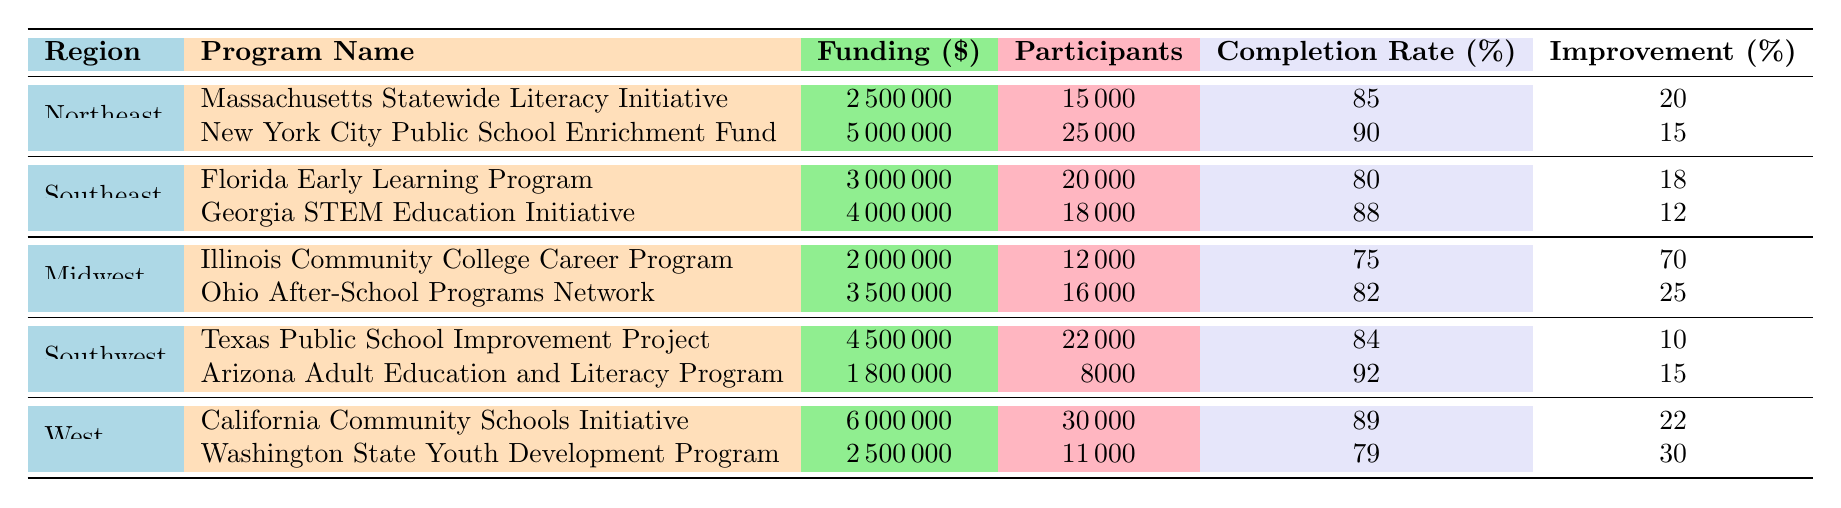What is the funding amount for the Georgia STEM Education Initiative? The table shows the Southeast region's programs. Looking at the entry for the Georgia STEM Education Initiative, the funding amount is listed as 4000000.
Answer: 4000000 Which region has the highest average completion rate among its programs? First, we calculate the average completion rates for each region: Northeast (87.5), Southeast (84), Midwest (78.5), Southwest (88), and West (84). The highest average is 88 from the Southwest region.
Answer: Southwest Did the Massachusetts Statewide Literacy Initiative improve literacy rates by more than 20 percent? The improvement in literacy rate for the Massachusetts Statewide Literacy Initiative is explicitly listed as 20 percent. Therefore, the statement is false.
Answer: No How many participants were there in total across all programs in the Midwest? To find the total participants in the Midwest, we add the numbers from both programs: 12000 (Illinois Community College Career Program) + 16000 (Ohio After-School Programs Network) = 28000.
Answer: 28000 Is the completion rate for the Florida Early Learning Program higher than that of the Texas Public School Improvement Project? The completion rate for the Florida Early Learning Program is 80 percent, while the Texas Public School Improvement Project has a completion rate of 84 percent, making this statement false.
Answer: No Which program in the West region had the highest funding amount? In the West region, we compare the funding amounts for both programs: California Community Schools Initiative at 6000000 and Washington State Youth Development Program at 2500000. The California Community Schools Initiative has the highest funding amount.
Answer: California Community Schools Initiative What is the total funding amount for all programs in the Northeast? First, we sum the funding amounts for the programs in the Northeast: 2500000 (Massachusetts Statewide Literacy Initiative) + 5000000 (New York City Public School Enrichment Fund) = 7500000.
Answer: 7500000 How does the improvement in employment rate for the Arizona Adult Education and Literacy Program compare to that of the Georgia STEM Education Initiative? The Arizona Adult Education and Literacy Program has an improvement of 15 percent in employment rate, while the Georgia STEM Education Initiative has an improvement of 12 percent. Hence, Arizona has a higher improvement rate.
Answer: Higher in Arizona What is the difference in completion rates between the California Community Schools Initiative and the Massachusetts Statewide Literacy Initiative? The completion rate for the California Community Schools Initiative is 89 percent, and for the Massachusetts Statewide Literacy Initiative, it is 85 percent. The difference is 89 - 85 = 4 percent.
Answer: 4 percent 